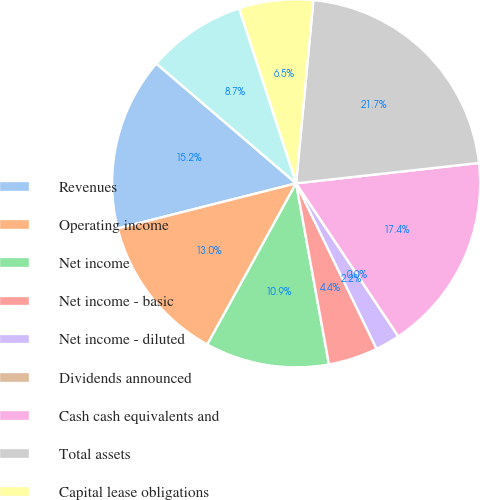Convert chart. <chart><loc_0><loc_0><loc_500><loc_500><pie_chart><fcel>Revenues<fcel>Operating income<fcel>Net income<fcel>Net income - basic<fcel>Net income - diluted<fcel>Dividends announced<fcel>Cash cash equivalents and<fcel>Total assets<fcel>Capital lease obligations<fcel>Other long-term liabilities<nl><fcel>15.22%<fcel>13.04%<fcel>10.87%<fcel>4.35%<fcel>2.17%<fcel>0.0%<fcel>17.39%<fcel>21.74%<fcel>6.52%<fcel>8.7%<nl></chart> 